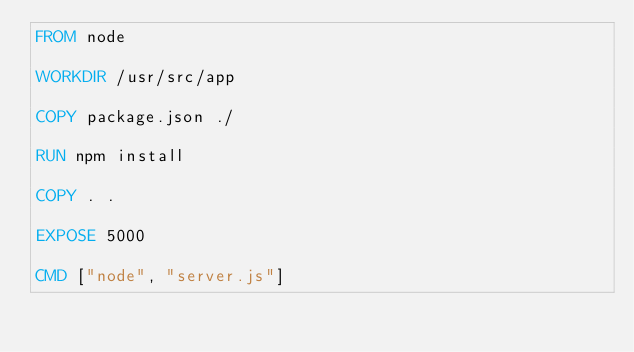<code> <loc_0><loc_0><loc_500><loc_500><_Dockerfile_>FROM node

WORKDIR /usr/src/app

COPY package.json ./

RUN npm install

COPY . .

EXPOSE 5000

CMD ["node", "server.js"]</code> 